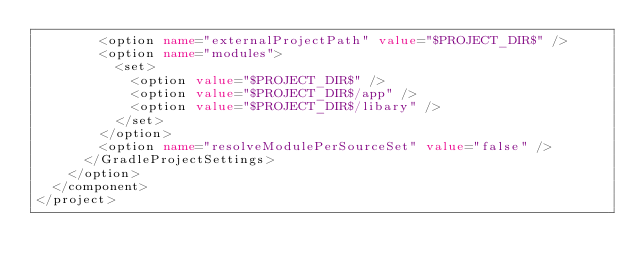<code> <loc_0><loc_0><loc_500><loc_500><_XML_>        <option name="externalProjectPath" value="$PROJECT_DIR$" />
        <option name="modules">
          <set>
            <option value="$PROJECT_DIR$" />
            <option value="$PROJECT_DIR$/app" />
            <option value="$PROJECT_DIR$/libary" />
          </set>
        </option>
        <option name="resolveModulePerSourceSet" value="false" />
      </GradleProjectSettings>
    </option>
  </component>
</project></code> 